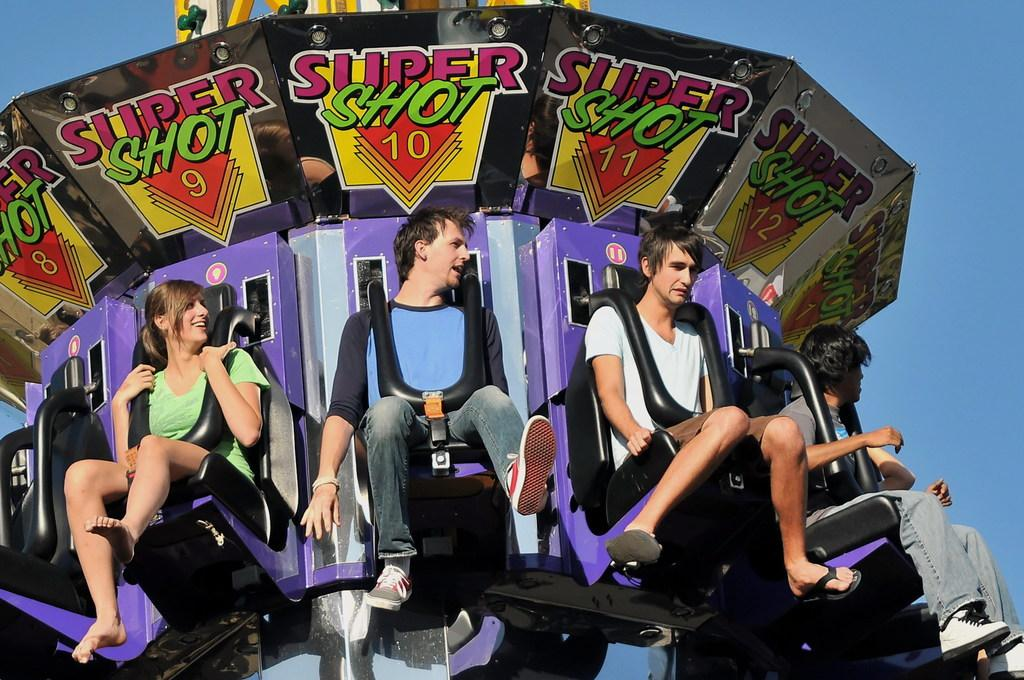Who or what can be seen in the image? There are people in the image. What are the people doing in the image? The people are sitting on a fun ride. What can be seen in the background of the image? There is sky visible in the background of the image. What type of vessel is being used by the actor in the image? There is no actor or vessel present in the image; it features people sitting on a fun ride with sky visible in the background. 